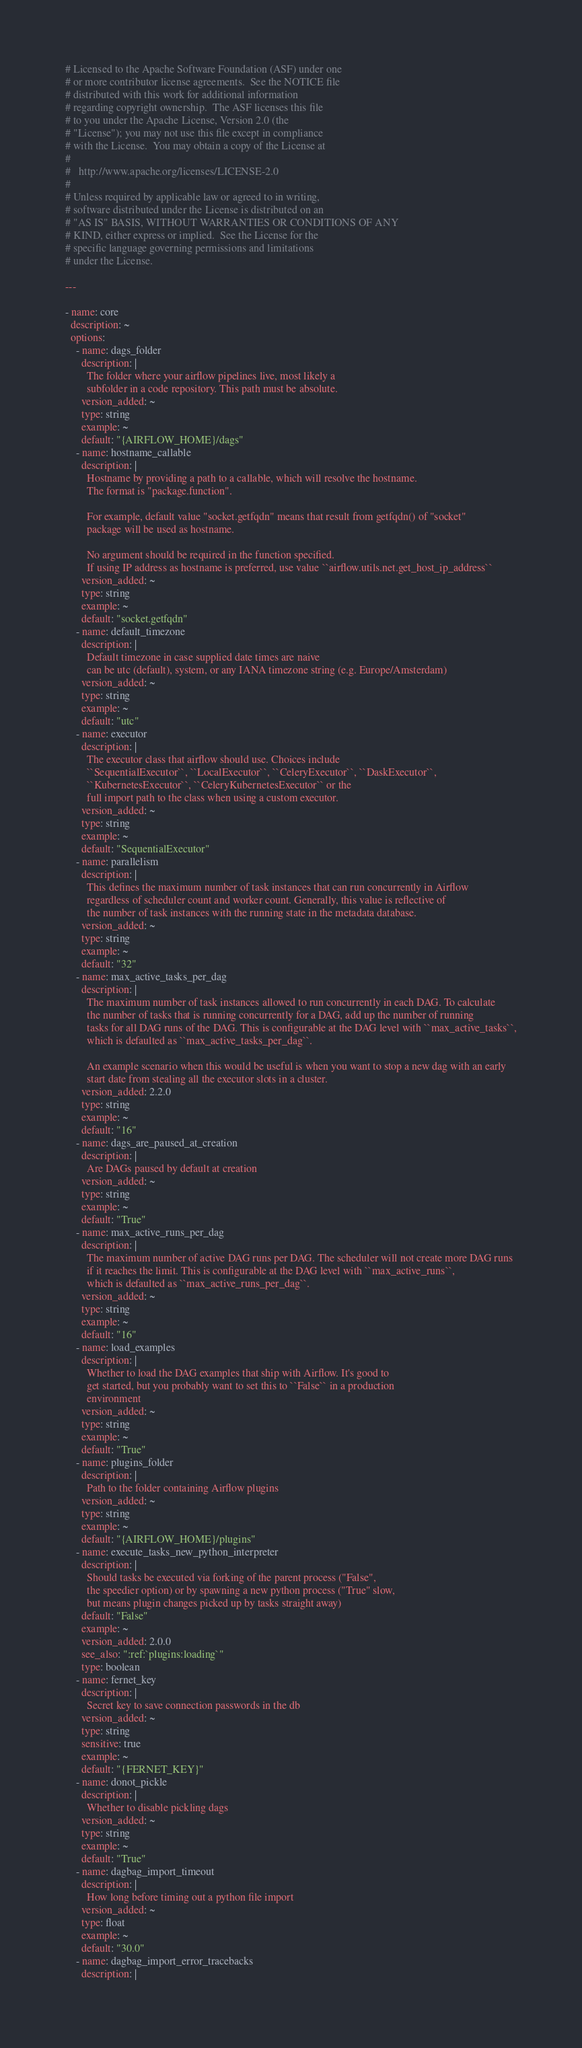<code> <loc_0><loc_0><loc_500><loc_500><_YAML_># Licensed to the Apache Software Foundation (ASF) under one
# or more contributor license agreements.  See the NOTICE file
# distributed with this work for additional information
# regarding copyright ownership.  The ASF licenses this file
# to you under the Apache License, Version 2.0 (the
# "License"); you may not use this file except in compliance
# with the License.  You may obtain a copy of the License at
#
#   http://www.apache.org/licenses/LICENSE-2.0
#
# Unless required by applicable law or agreed to in writing,
# software distributed under the License is distributed on an
# "AS IS" BASIS, WITHOUT WARRANTIES OR CONDITIONS OF ANY
# KIND, either express or implied.  See the License for the
# specific language governing permissions and limitations
# under the License.

---

- name: core
  description: ~
  options:
    - name: dags_folder
      description: |
        The folder where your airflow pipelines live, most likely a
        subfolder in a code repository. This path must be absolute.
      version_added: ~
      type: string
      example: ~
      default: "{AIRFLOW_HOME}/dags"
    - name: hostname_callable
      description: |
        Hostname by providing a path to a callable, which will resolve the hostname.
        The format is "package.function".

        For example, default value "socket.getfqdn" means that result from getfqdn() of "socket"
        package will be used as hostname.

        No argument should be required in the function specified.
        If using IP address as hostname is preferred, use value ``airflow.utils.net.get_host_ip_address``
      version_added: ~
      type: string
      example: ~
      default: "socket.getfqdn"
    - name: default_timezone
      description: |
        Default timezone in case supplied date times are naive
        can be utc (default), system, or any IANA timezone string (e.g. Europe/Amsterdam)
      version_added: ~
      type: string
      example: ~
      default: "utc"
    - name: executor
      description: |
        The executor class that airflow should use. Choices include
        ``SequentialExecutor``, ``LocalExecutor``, ``CeleryExecutor``, ``DaskExecutor``,
        ``KubernetesExecutor``, ``CeleryKubernetesExecutor`` or the
        full import path to the class when using a custom executor.
      version_added: ~
      type: string
      example: ~
      default: "SequentialExecutor"
    - name: parallelism
      description: |
        This defines the maximum number of task instances that can run concurrently in Airflow
        regardless of scheduler count and worker count. Generally, this value is reflective of
        the number of task instances with the running state in the metadata database.
      version_added: ~
      type: string
      example: ~
      default: "32"
    - name: max_active_tasks_per_dag
      description: |
        The maximum number of task instances allowed to run concurrently in each DAG. To calculate
        the number of tasks that is running concurrently for a DAG, add up the number of running
        tasks for all DAG runs of the DAG. This is configurable at the DAG level with ``max_active_tasks``,
        which is defaulted as ``max_active_tasks_per_dag``.

        An example scenario when this would be useful is when you want to stop a new dag with an early
        start date from stealing all the executor slots in a cluster.
      version_added: 2.2.0
      type: string
      example: ~
      default: "16"
    - name: dags_are_paused_at_creation
      description: |
        Are DAGs paused by default at creation
      version_added: ~
      type: string
      example: ~
      default: "True"
    - name: max_active_runs_per_dag
      description: |
        The maximum number of active DAG runs per DAG. The scheduler will not create more DAG runs
        if it reaches the limit. This is configurable at the DAG level with ``max_active_runs``,
        which is defaulted as ``max_active_runs_per_dag``.
      version_added: ~
      type: string
      example: ~
      default: "16"
    - name: load_examples
      description: |
        Whether to load the DAG examples that ship with Airflow. It's good to
        get started, but you probably want to set this to ``False`` in a production
        environment
      version_added: ~
      type: string
      example: ~
      default: "True"
    - name: plugins_folder
      description: |
        Path to the folder containing Airflow plugins
      version_added: ~
      type: string
      example: ~
      default: "{AIRFLOW_HOME}/plugins"
    - name: execute_tasks_new_python_interpreter
      description: |
        Should tasks be executed via forking of the parent process ("False",
        the speedier option) or by spawning a new python process ("True" slow,
        but means plugin changes picked up by tasks straight away)
      default: "False"
      example: ~
      version_added: 2.0.0
      see_also: ":ref:`plugins:loading`"
      type: boolean
    - name: fernet_key
      description: |
        Secret key to save connection passwords in the db
      version_added: ~
      type: string
      sensitive: true
      example: ~
      default: "{FERNET_KEY}"
    - name: donot_pickle
      description: |
        Whether to disable pickling dags
      version_added: ~
      type: string
      example: ~
      default: "True"
    - name: dagbag_import_timeout
      description: |
        How long before timing out a python file import
      version_added: ~
      type: float
      example: ~
      default: "30.0"
    - name: dagbag_import_error_tracebacks
      description: |</code> 